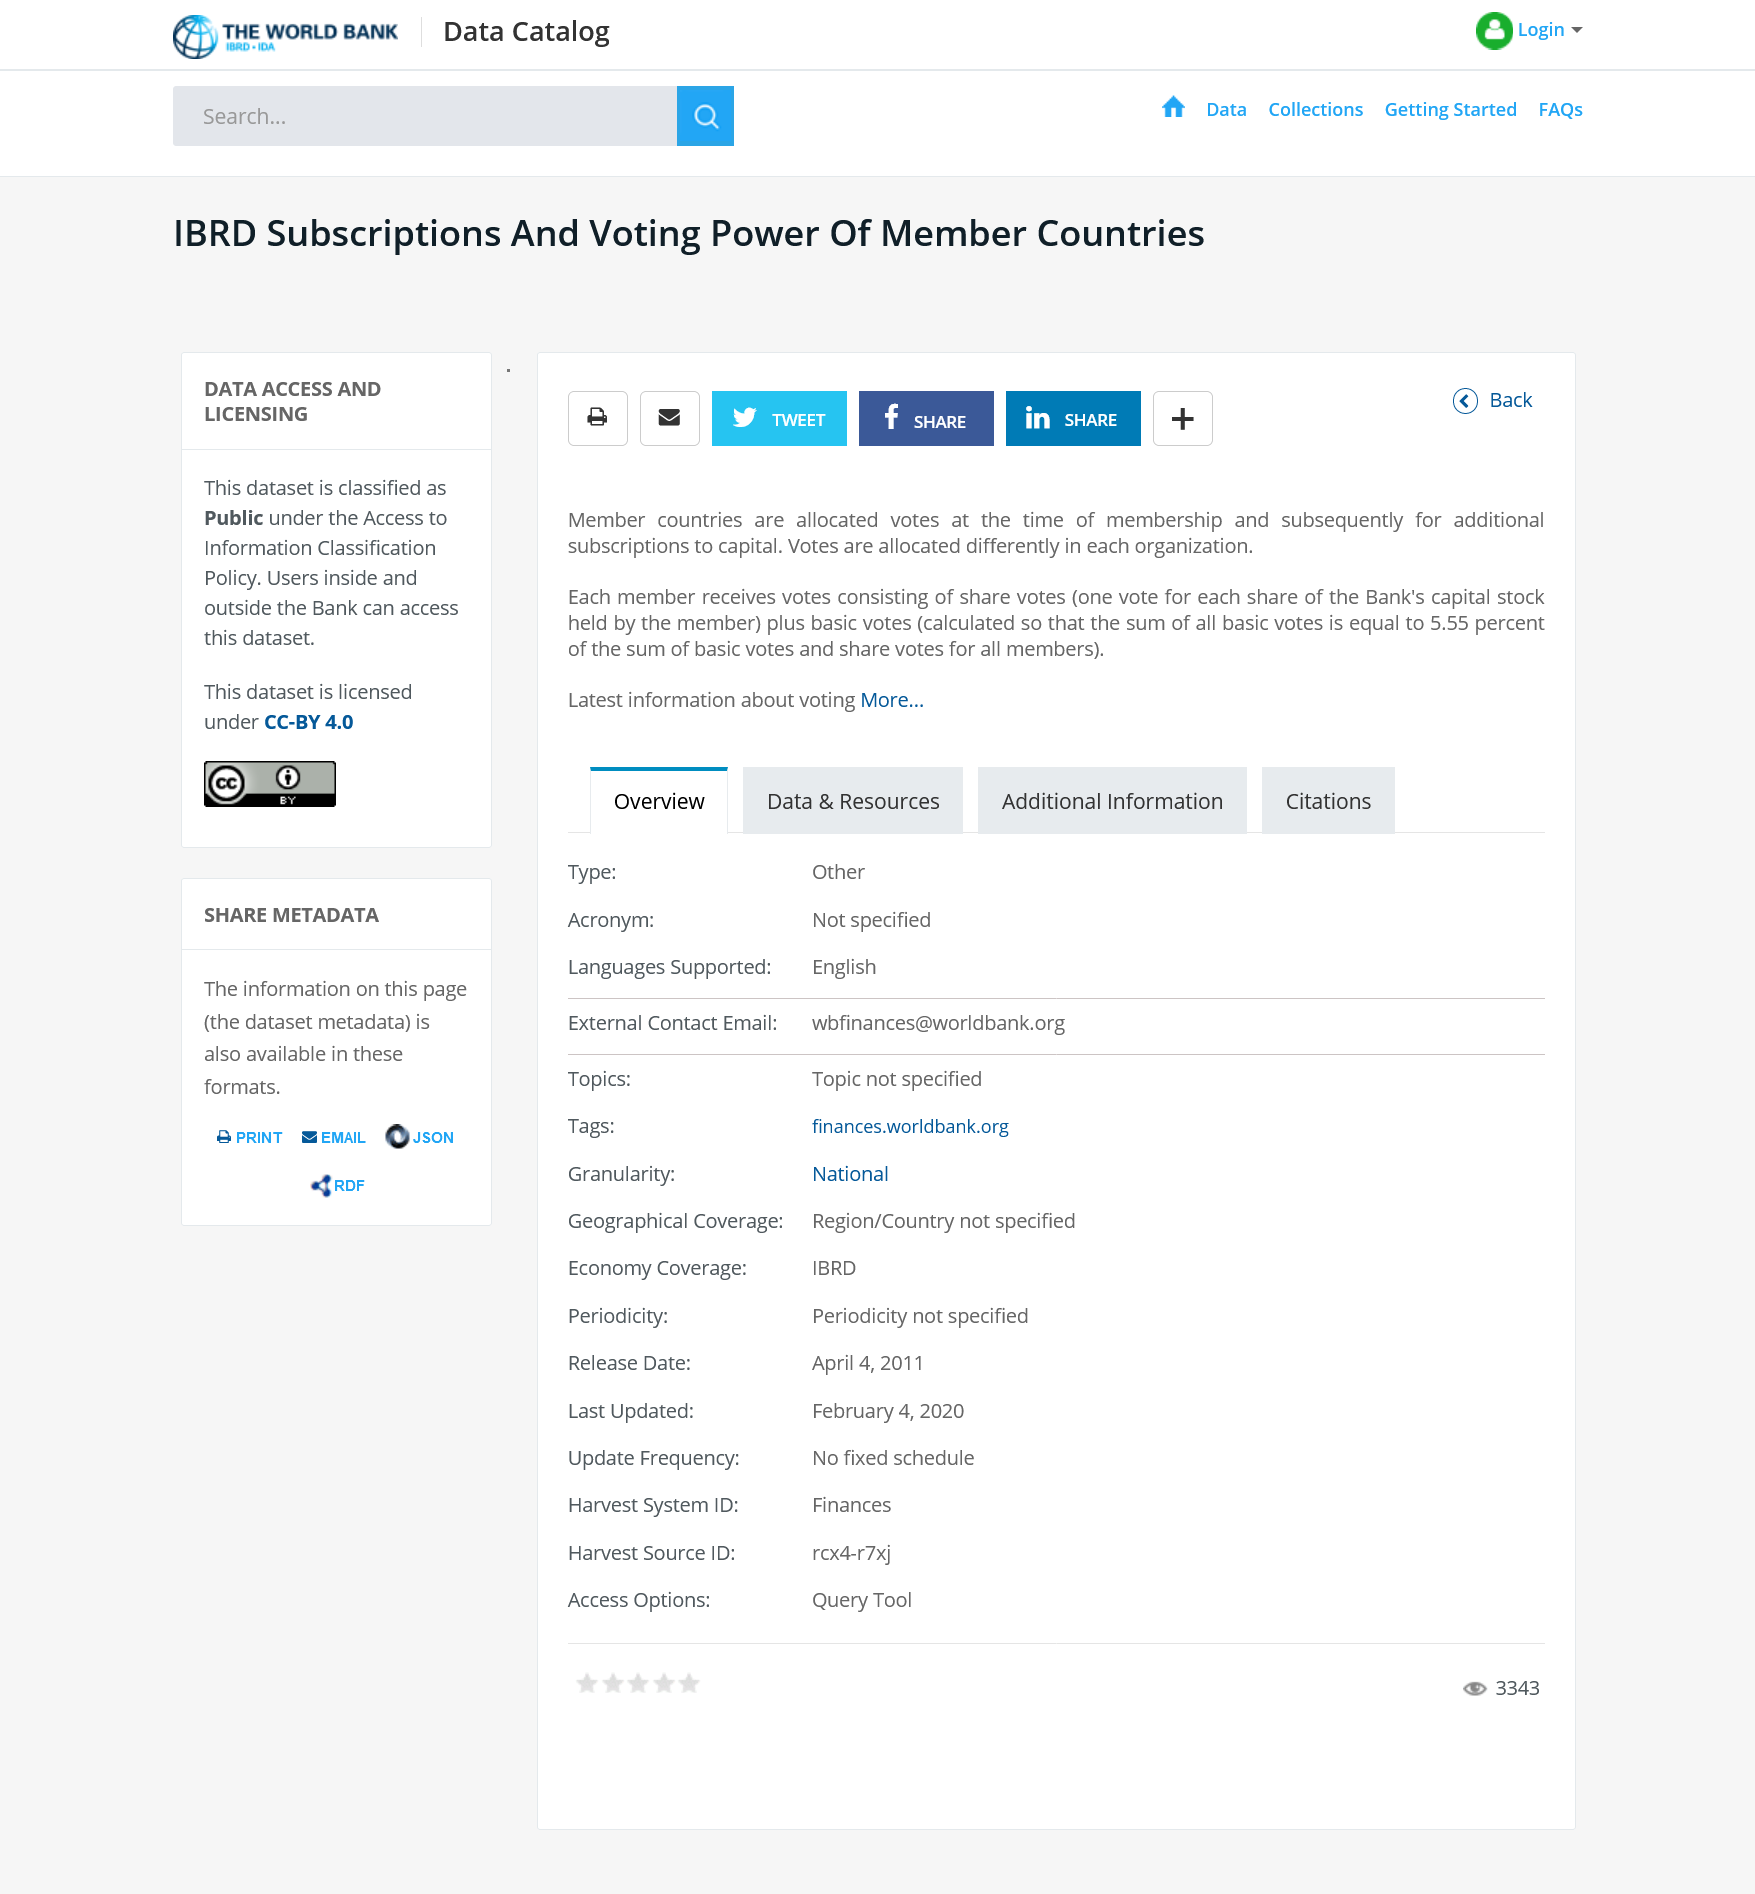Draw attention to some important aspects in this diagram. The allocation of votes for member countries at the World Bank Group's International Bank for Reconstruction and Development (IBRD) is based on their level of membership and subsequent subscriptions to capital. These votes are granted at the time of a country's initial membership and are maintained for any additional subscriptions to the IBRD's capital. Each member is entitled to one vote for each share of the Bank's capital stock that they hold. Each member of the company is entitled to receive two types of votes in the general meeting of shareholders: share votes and basic votes. Share votes are based on the number of shares owned by the member, while basic votes are granted to all members equally, regardless of the number of shares they own. 